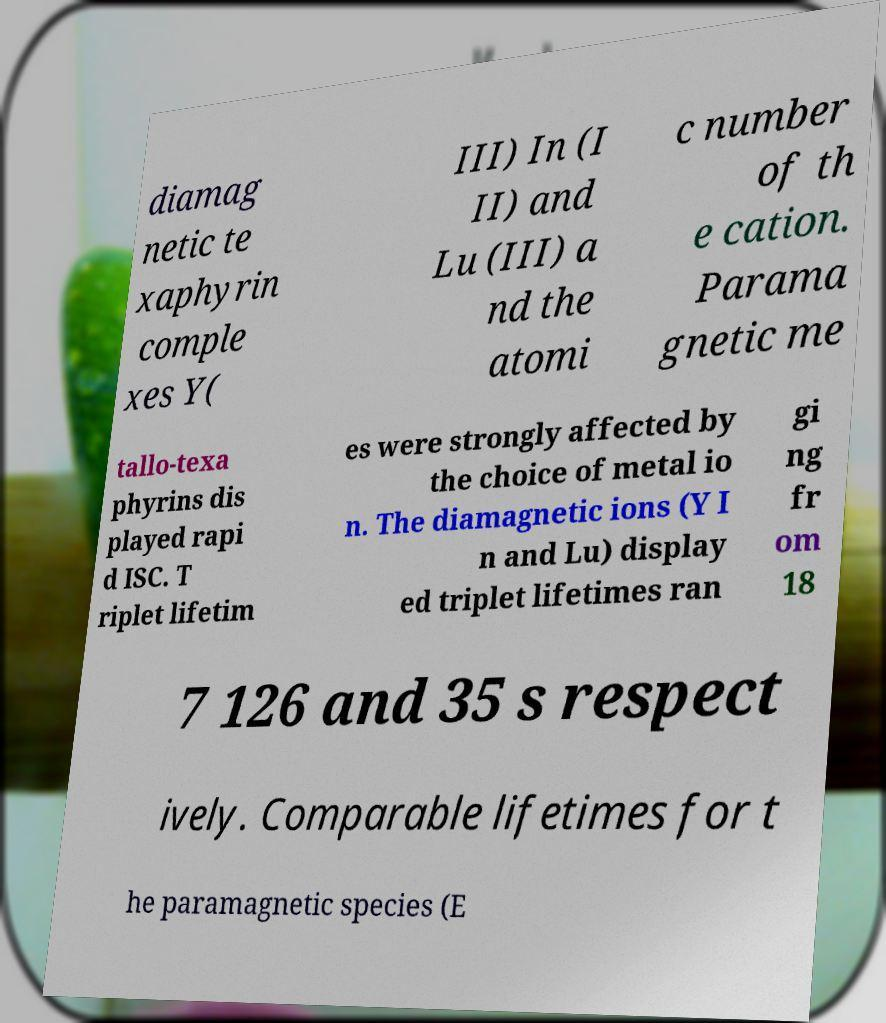Could you extract and type out the text from this image? diamag netic te xaphyrin comple xes Y( III) In (I II) and Lu (III) a nd the atomi c number of th e cation. Parama gnetic me tallo-texa phyrins dis played rapi d ISC. T riplet lifetim es were strongly affected by the choice of metal io n. The diamagnetic ions (Y I n and Lu) display ed triplet lifetimes ran gi ng fr om 18 7 126 and 35 s respect ively. Comparable lifetimes for t he paramagnetic species (E 